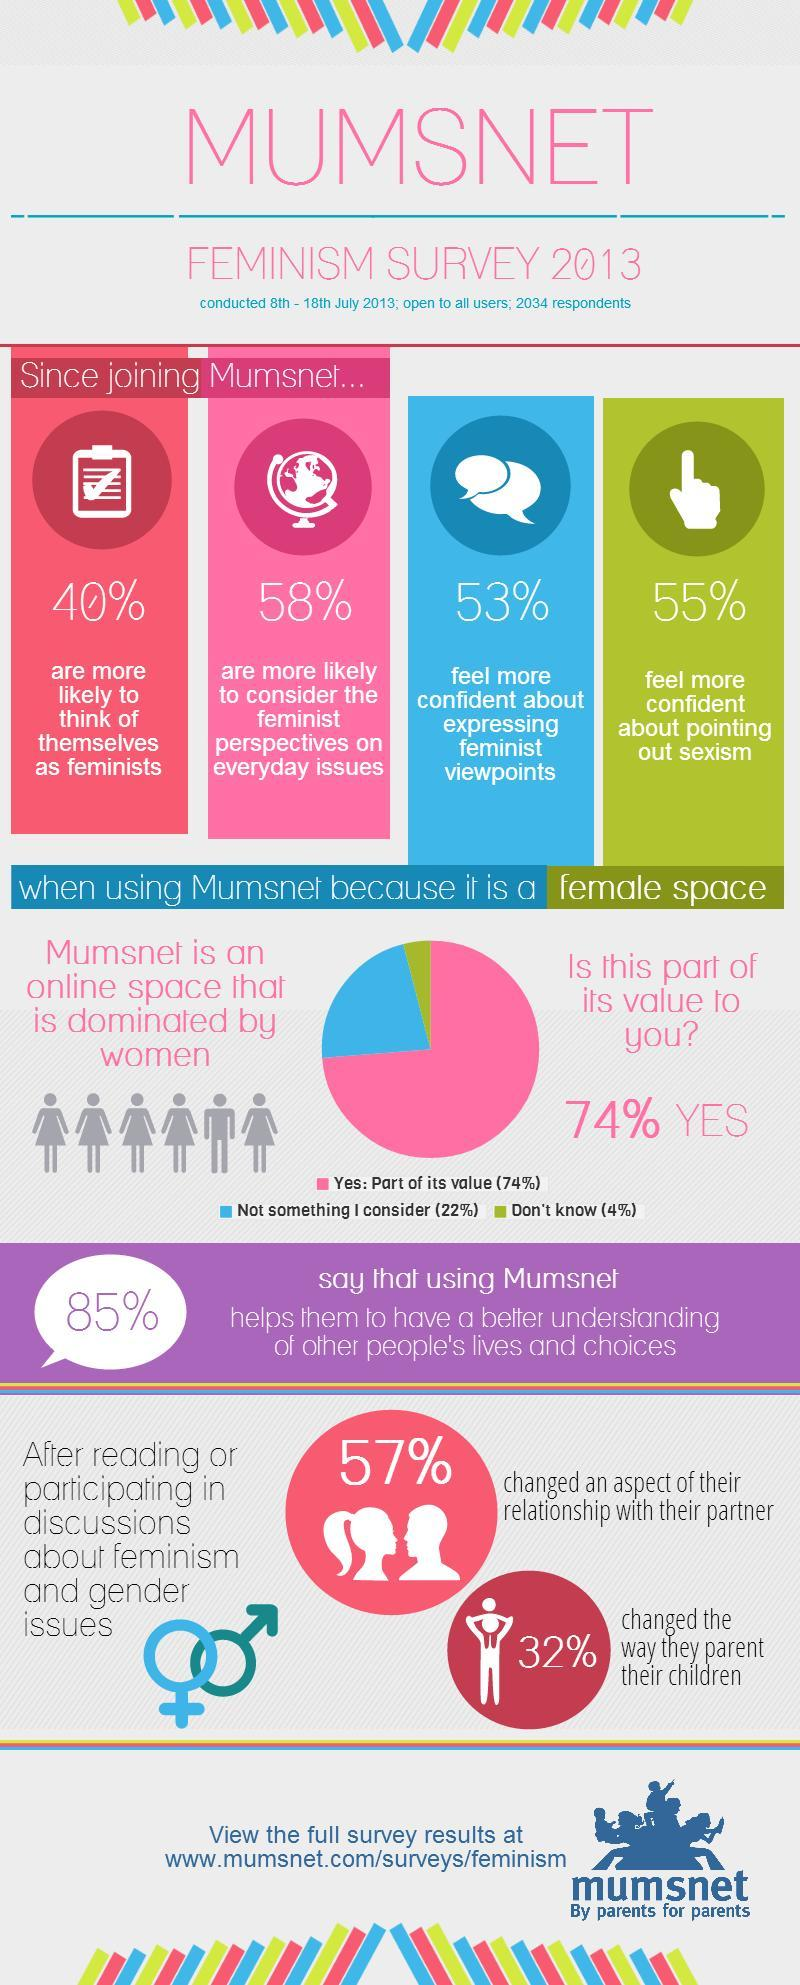What percentage of respondents are more likely to think of themselves as feminists since joining the Mumsnet  as per the feminism survey in 2013?
Answer the question with a short phrase. 40% What percent of people changed the way of parenting their children after reading or participating in discussions about feminism & gender issues? 32% What percentage of the respondents felt more confident about pointing out sexism since joining the Mumsnet  as per the feminism survey in 2013? 55% What percentage of the respondents felt more confident about expressing feminist viewpoints since joining the Mumsnet as per the feminism survey in 2013? 53% 